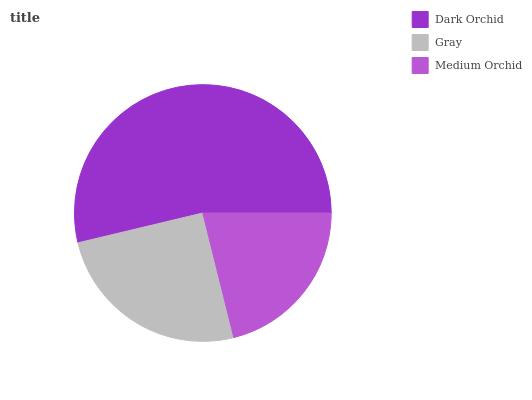Is Medium Orchid the minimum?
Answer yes or no. Yes. Is Dark Orchid the maximum?
Answer yes or no. Yes. Is Gray the minimum?
Answer yes or no. No. Is Gray the maximum?
Answer yes or no. No. Is Dark Orchid greater than Gray?
Answer yes or no. Yes. Is Gray less than Dark Orchid?
Answer yes or no. Yes. Is Gray greater than Dark Orchid?
Answer yes or no. No. Is Dark Orchid less than Gray?
Answer yes or no. No. Is Gray the high median?
Answer yes or no. Yes. Is Gray the low median?
Answer yes or no. Yes. Is Medium Orchid the high median?
Answer yes or no. No. Is Medium Orchid the low median?
Answer yes or no. No. 